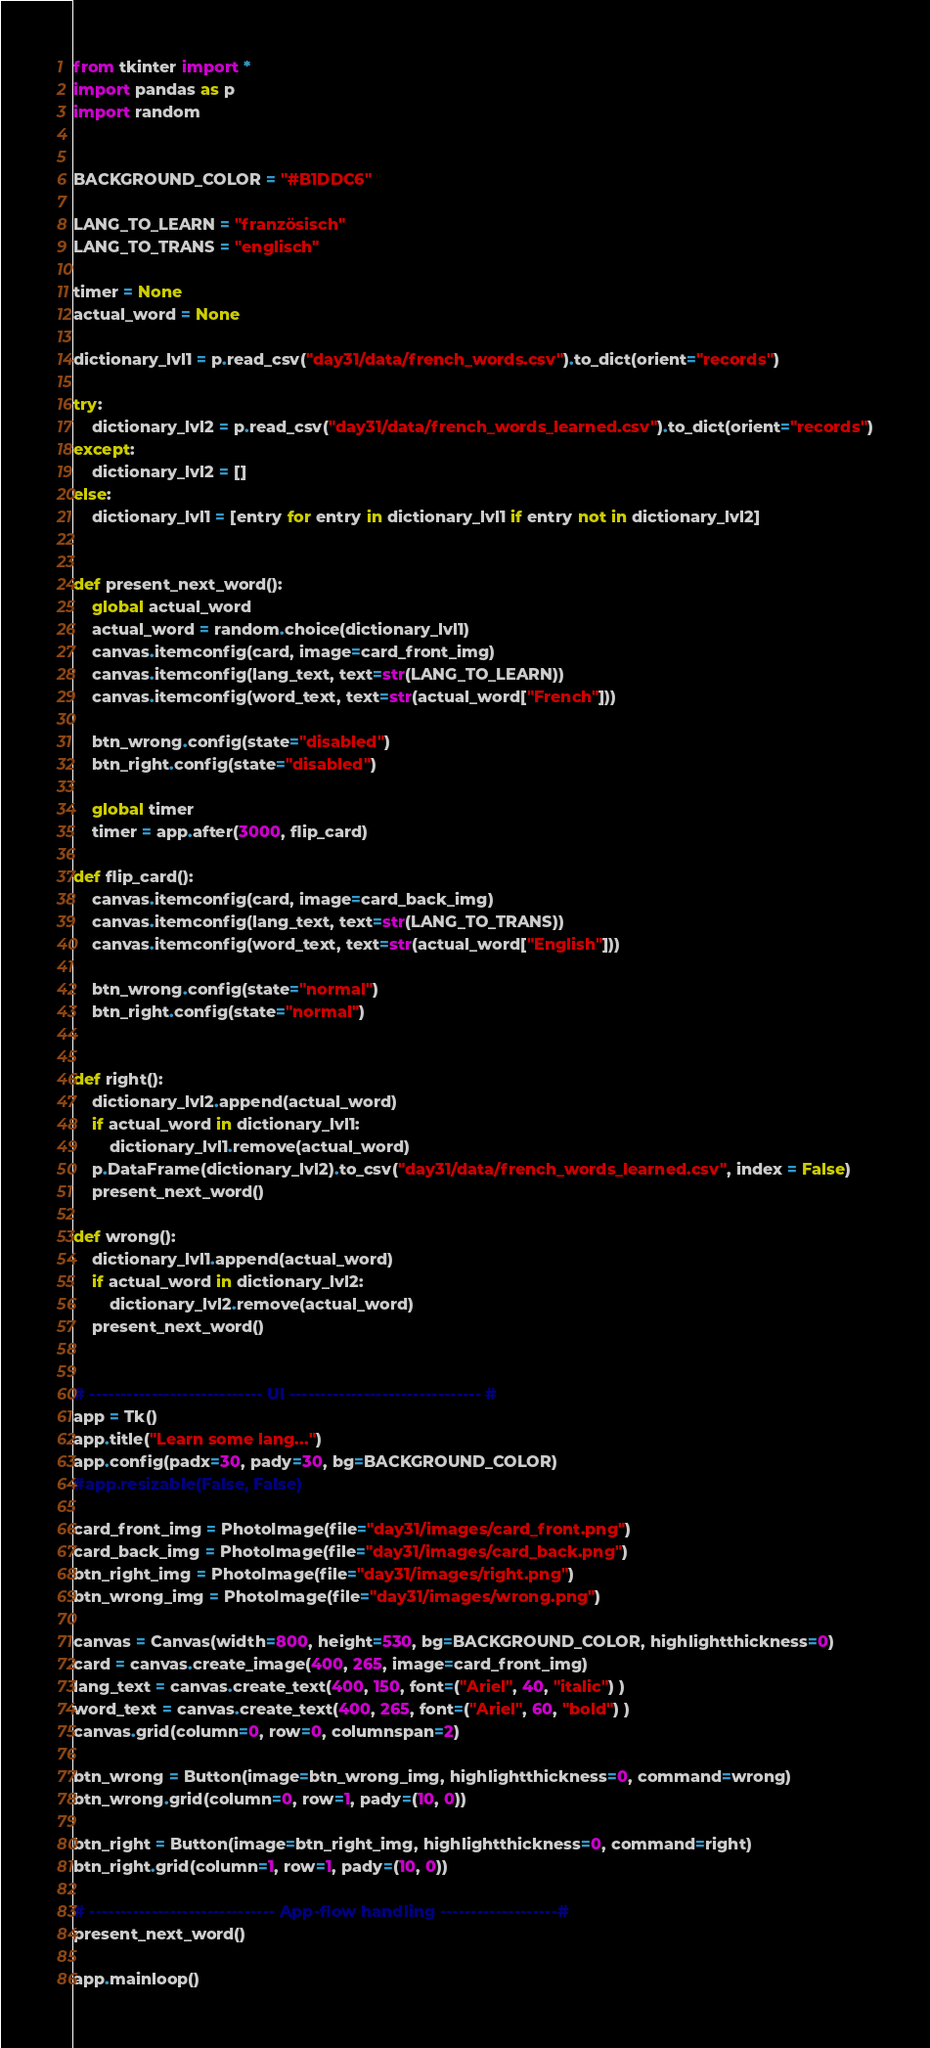Convert code to text. <code><loc_0><loc_0><loc_500><loc_500><_Python_>from tkinter import *
import pandas as p
import random


BACKGROUND_COLOR = "#B1DDC6"

LANG_TO_LEARN = "französisch"
LANG_TO_TRANS = "englisch"

timer = None
actual_word = None

dictionary_lvl1 = p.read_csv("day31/data/french_words.csv").to_dict(orient="records")

try:
    dictionary_lvl2 = p.read_csv("day31/data/french_words_learned.csv").to_dict(orient="records")
except:
    dictionary_lvl2 = []
else:
    dictionary_lvl1 = [entry for entry in dictionary_lvl1 if entry not in dictionary_lvl2]


def present_next_word():
    global actual_word
    actual_word = random.choice(dictionary_lvl1)
    canvas.itemconfig(card, image=card_front_img)
    canvas.itemconfig(lang_text, text=str(LANG_TO_LEARN))
    canvas.itemconfig(word_text, text=str(actual_word["French"]))

    btn_wrong.config(state="disabled")
    btn_right.config(state="disabled")

    global timer
    timer = app.after(3000, flip_card)

def flip_card():
    canvas.itemconfig(card, image=card_back_img)
    canvas.itemconfig(lang_text, text=str(LANG_TO_TRANS))
    canvas.itemconfig(word_text, text=str(actual_word["English"]))

    btn_wrong.config(state="normal")
    btn_right.config(state="normal")
    

def right():
    dictionary_lvl2.append(actual_word)
    if actual_word in dictionary_lvl1:
        dictionary_lvl1.remove(actual_word)
    p.DataFrame(dictionary_lvl2).to_csv("day31/data/french_words_learned.csv", index = False)
    present_next_word()

def wrong():
    dictionary_lvl1.append(actual_word)
    if actual_word in dictionary_lvl2:
        dictionary_lvl2.remove(actual_word)
    present_next_word()


# ---------------------------- UI ------------------------------- #
app = Tk()
app.title("Learn some lang...")
app.config(padx=30, pady=30, bg=BACKGROUND_COLOR)
#app.resizable(False, False)

card_front_img = PhotoImage(file="day31/images/card_front.png")
card_back_img = PhotoImage(file="day31/images/card_back.png")
btn_right_img = PhotoImage(file="day31/images/right.png")
btn_wrong_img = PhotoImage(file="day31/images/wrong.png")

canvas = Canvas(width=800, height=530, bg=BACKGROUND_COLOR, highlightthickness=0)
card = canvas.create_image(400, 265, image=card_front_img)
lang_text = canvas.create_text(400, 150, font=("Ariel", 40, "italic") )
word_text = canvas.create_text(400, 265, font=("Ariel", 60, "bold") )
canvas.grid(column=0, row=0, columnspan=2)

btn_wrong = Button(image=btn_wrong_img, highlightthickness=0, command=wrong)
btn_wrong.grid(column=0, row=1, pady=(10, 0))

btn_right = Button(image=btn_right_img, highlightthickness=0, command=right)
btn_right.grid(column=1, row=1, pady=(10, 0))

# ------------------------------ App-flow handling -------------------#
present_next_word()

app.mainloop()</code> 